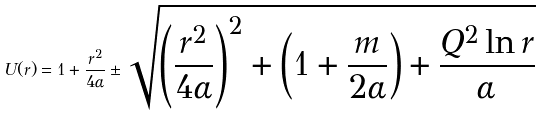<formula> <loc_0><loc_0><loc_500><loc_500>U ( r ) = 1 + \frac { r ^ { 2 } } { 4 \alpha } \pm \sqrt { \left ( \frac { r ^ { 2 } } { 4 \alpha } \right ) ^ { 2 } + \left ( 1 + \frac { m } { 2 \alpha } \right ) + \frac { Q ^ { 2 } \ln r } { \alpha } }</formula> 